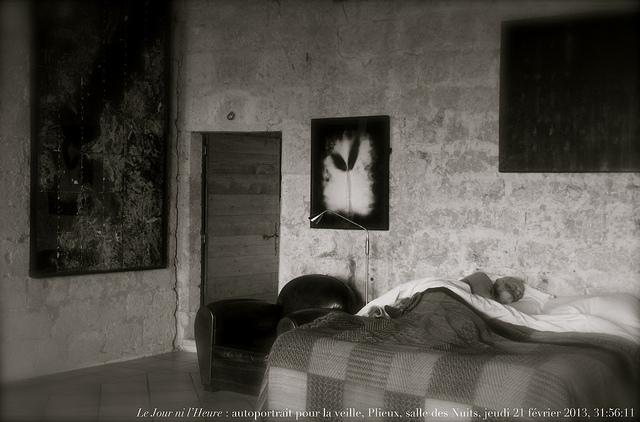What color is the wall?
Give a very brief answer. White. How many pictures are hanging in the room?
Concise answer only. 3. Is there a person sleeping in the bed?
Keep it brief. Yes. Is this photo outdoors?
Give a very brief answer. No. Is it sunny?
Keep it brief. No. 